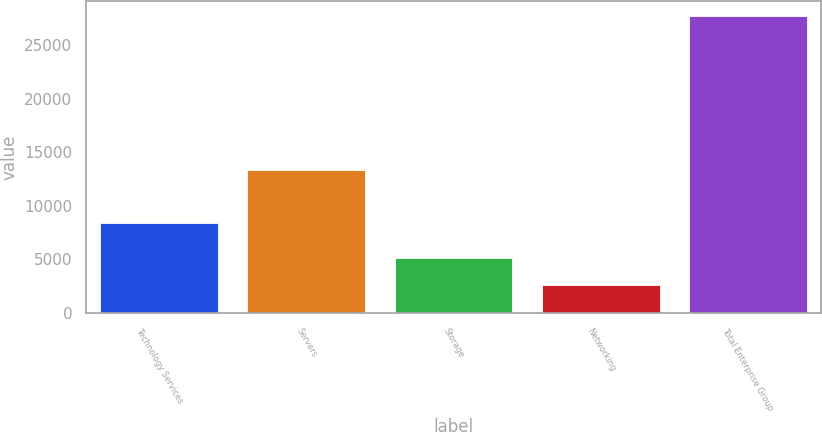<chart> <loc_0><loc_0><loc_500><loc_500><bar_chart><fcel>Technology Services<fcel>Servers<fcel>Storage<fcel>Networking<fcel>Total Enterprise Group<nl><fcel>8383<fcel>13401<fcel>5137.9<fcel>2628<fcel>27727<nl></chart> 